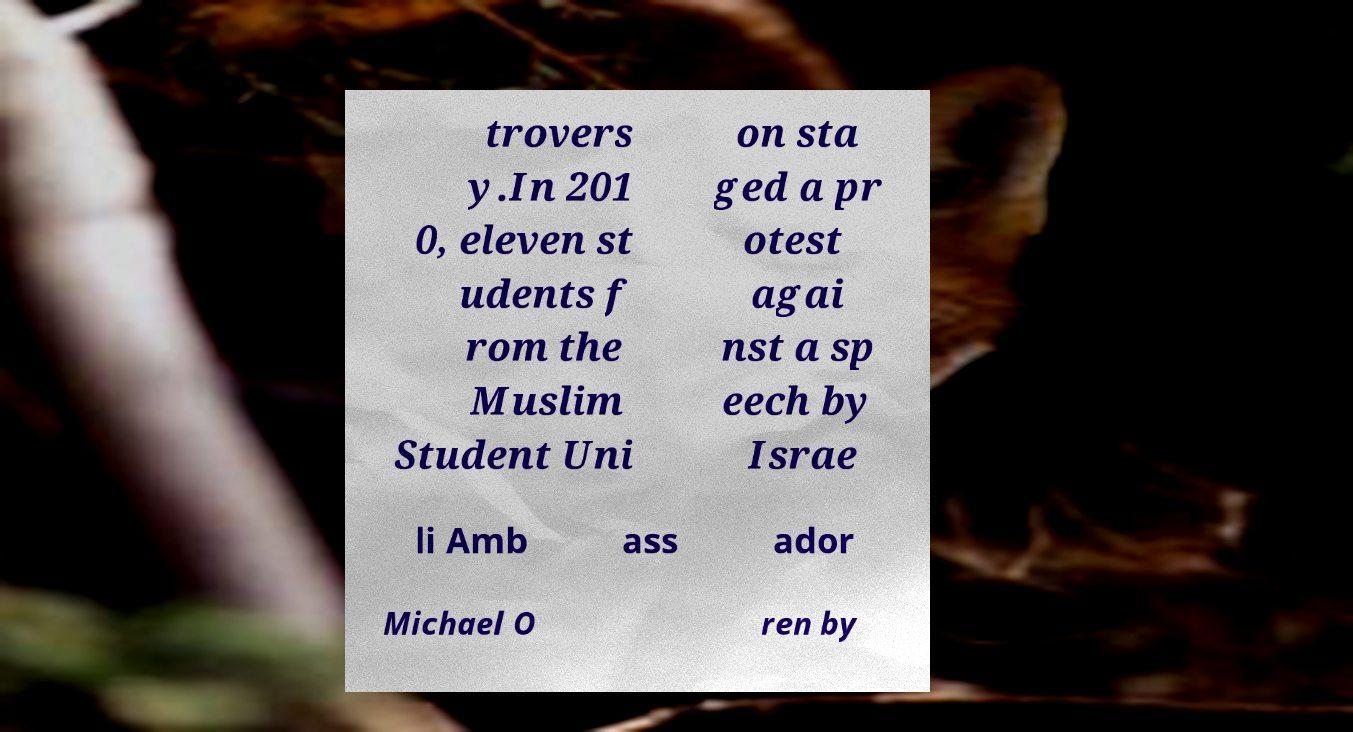I need the written content from this picture converted into text. Can you do that? trovers y.In 201 0, eleven st udents f rom the Muslim Student Uni on sta ged a pr otest agai nst a sp eech by Israe li Amb ass ador Michael O ren by 